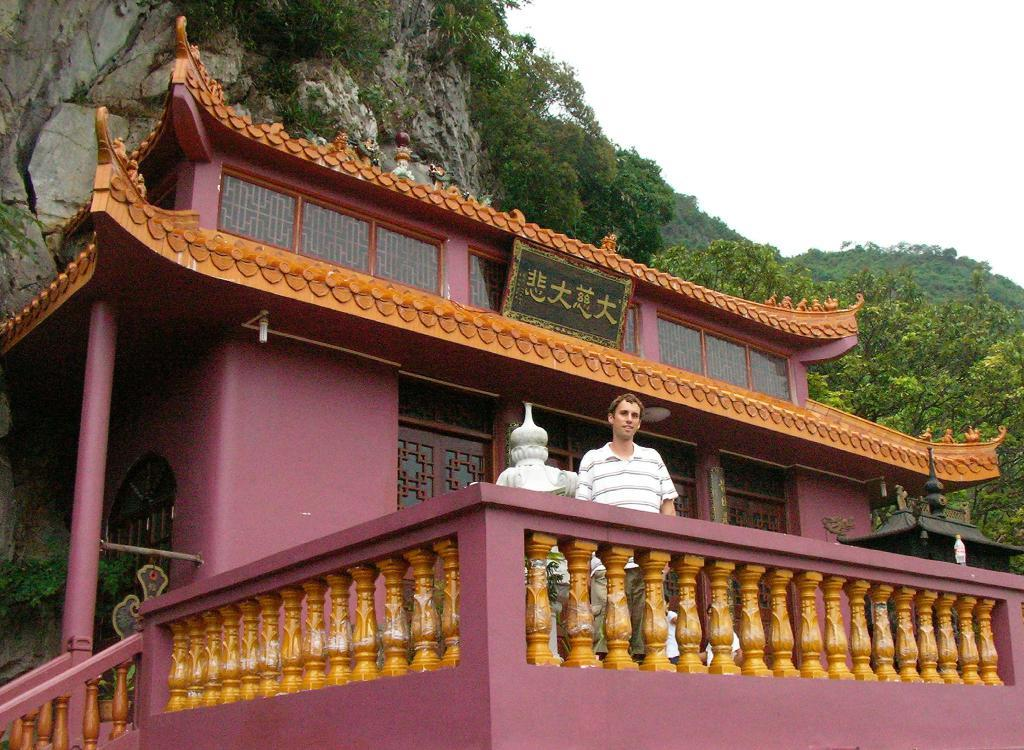What type of architecture is featured in the image? There is Chinese ancient architecture in the image. What can be seen surrounding the architecture? There is a fence in the image. Are there any people present in the image? Yes, there is a person can be seen in the image. What other elements are present in the image? There are plants and a board visible in the image. What can be seen in the background of the image? There is a mountain, trees, and the sky visible in the background of the image. What type of trousers is the mountain wearing in the image? The mountain is not wearing any trousers, as it is a geographical feature and not a person. 